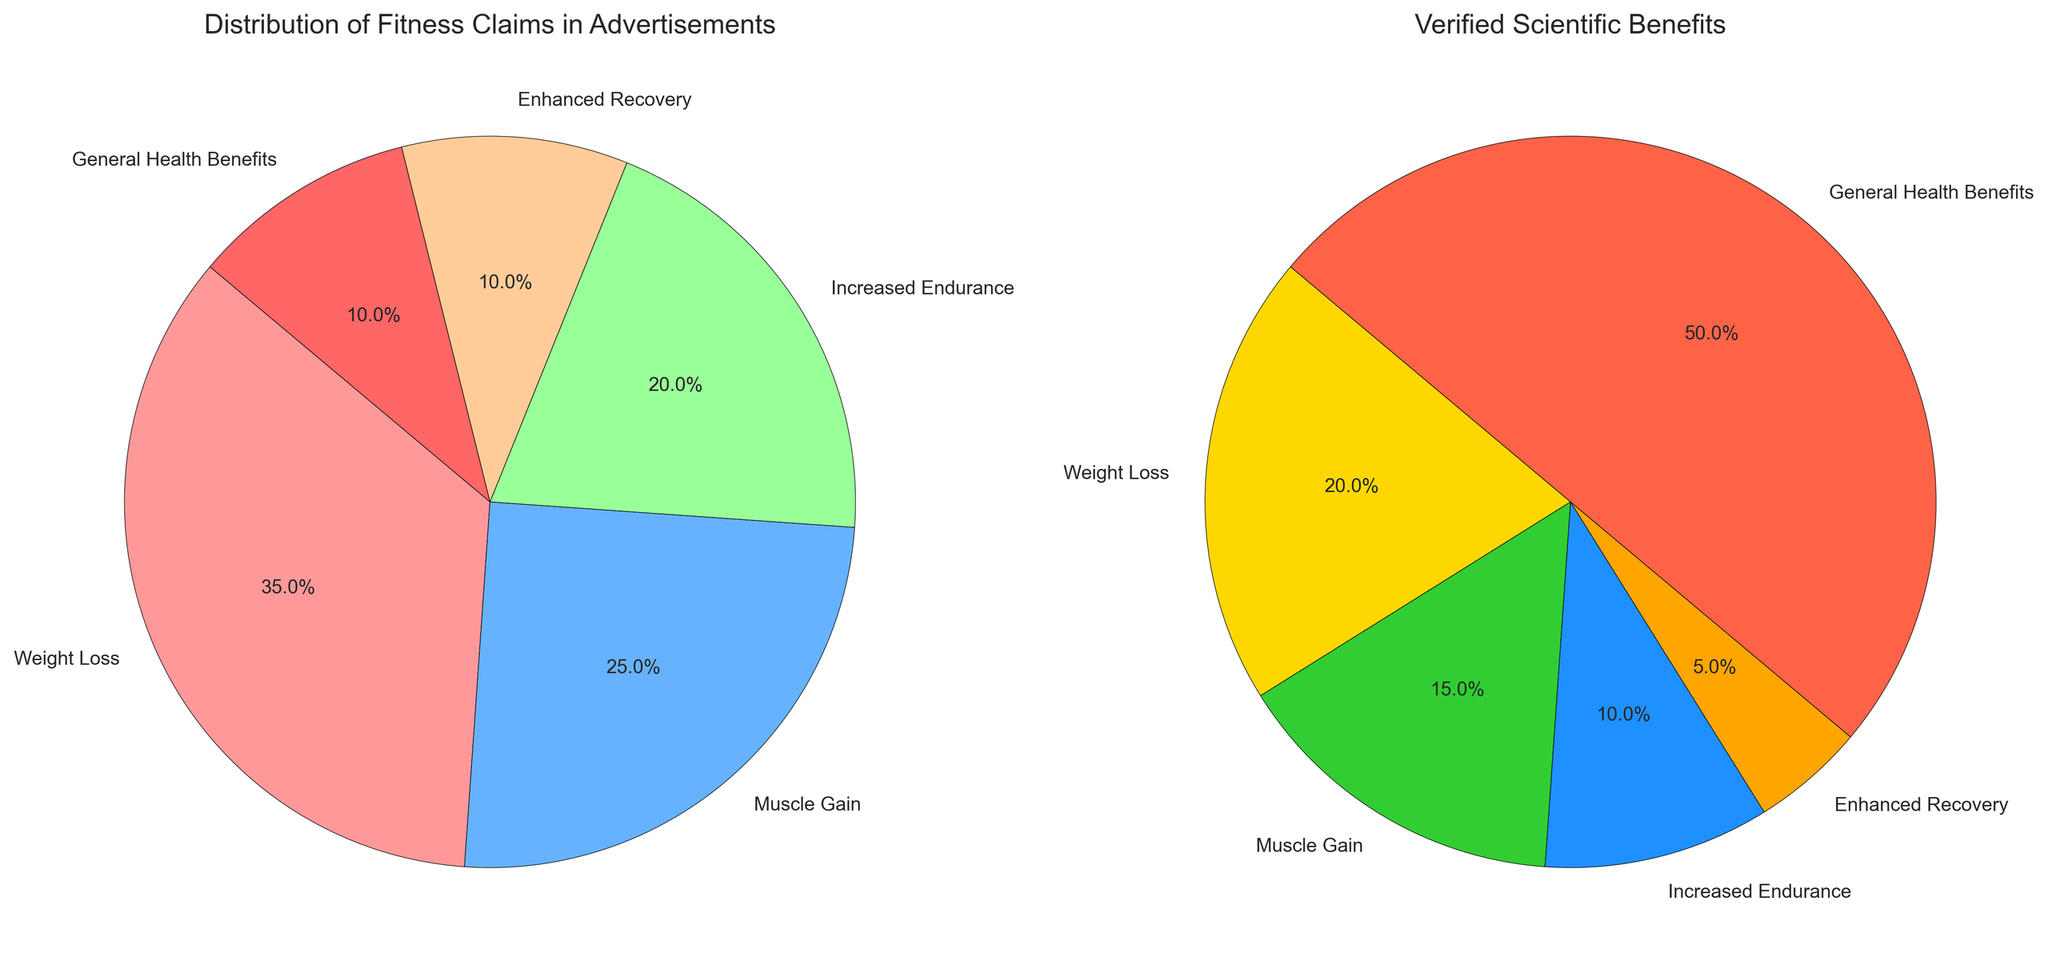What's the most frequently claimed benefit in advertisements? Look at the slice sizes in the "Distribution of Fitness Claims in Advertisements" pie chart to identify the largest segment. "Weight Loss" has the largest segment, indicating it is the most frequently claimed.
Answer: Weight Loss What percentage of scientific benefits does General Health Benefits cover? Look at the slice labeled "General Health Benefits" in the "Verified Scientific Benefits" pie chart for its percentage. The label shows 50%.
Answer: 50% How much more frequently is weight loss claimed in advertisements compared to its scientific backing? Subtract the percentage of "Weight Loss" in the "Verified Scientific Benefits" pie chart from the percentage in the "Distribution of Fitness Claims in Advertisements" pie chart: 35% - 20% = 15%.
Answer: 15% Which benefit has the smallest discrepancy between its advertisement claim and scientific backing? Calculate the absolute difference for each benefit between its advertisement claim and scientific backing. "General Health Benefits" has a 40% difference, "Enhanced Recovery" has a 5% difference, "Increased Endurance" has a 10% difference, "Muscle Gain" has a 10% difference, and "Weight Loss" has a 15% difference. "Enhanced Recovery" has the smallest discrepancy (5%).
Answer: Enhanced Recovery Which claim appears to be least justified scientifically? Identify the claim with the smallest percentage in the "Verified Scientific Benefits" chart. "Enhanced Recovery" has the smallest scientific backing at 5%.
Answer: Enhanced Recovery What is the total percentage cover of increased endurance in both advertisements and scientific data? Add the percentages for "Increased Endurance" in both pie charts: 20% (Advertisement) + 10% (Scientific) = 30%.
Answer: 30% Comparing "Muscle Gain" and "General Health Benefits," which is promoted more in advertisements? Compare the percentages for "Muscle Gain" and "General Health Benefits" in the "Distribution of Fitness Claims in Advertisements" pie chart. "Muscle Gain" is promoted at 25% whereas "General Health Benefits" is promoted at 10%.
Answer: Muscle Gain How does the scientific backing for weight loss compare to that for gaining muscle? Compare the percentages for "Weight Loss" and "Muscle Gain" in the "Verified Scientific Benefits" pie chart: Weight Loss is at 20%, and Muscle Gain is at 15%.
Answer: Weight Loss is higher Which visual cue helps to immediately differentiate between the two pie charts in terms of what they represent? The titles of the two pie charts immediately differentiate them: "Distribution of Fitness Claims in Advertisements" and "Verified Scientific Benefits."
Answer: Titles What percentage more do advertisements claim for Muscle Gain compared to its scientific backing? Subtract the scientific percentage (15%) from the advertisement percentage (25%) for muscle gain. 25% - 15% = 10%.
Answer: 10% 